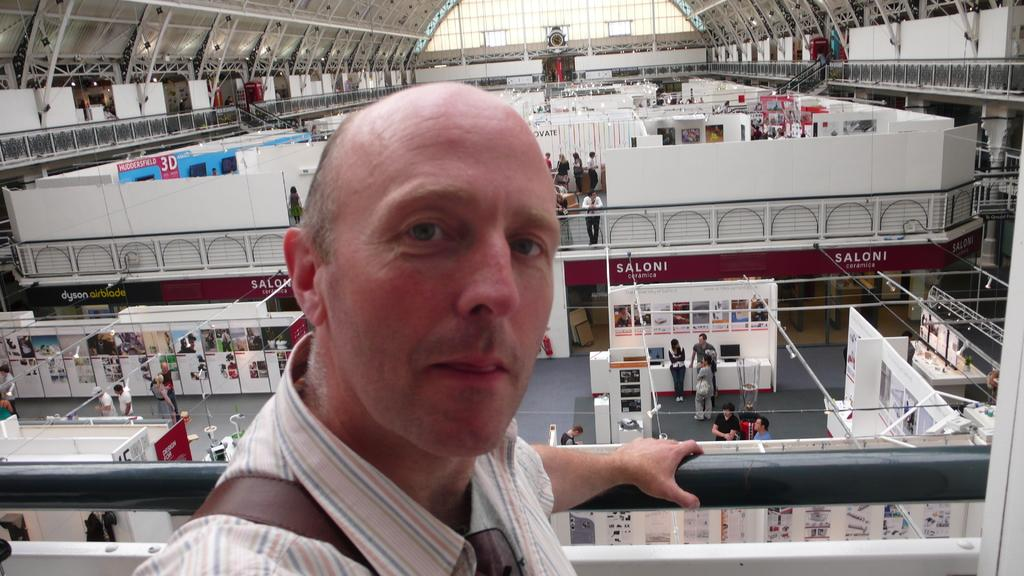Who or what is the main subject in the image? There is a person in the image. What can be seen in the background of the image? There is a building visible in the background. What is happening inside the building? There are people standing inside the building. What type of clothing or accessory is present in the image? There are stoles present in the image. How many feet of wire are visible in the image? There is no wire present in the image, so it is not possible to determine the length of any wire. 